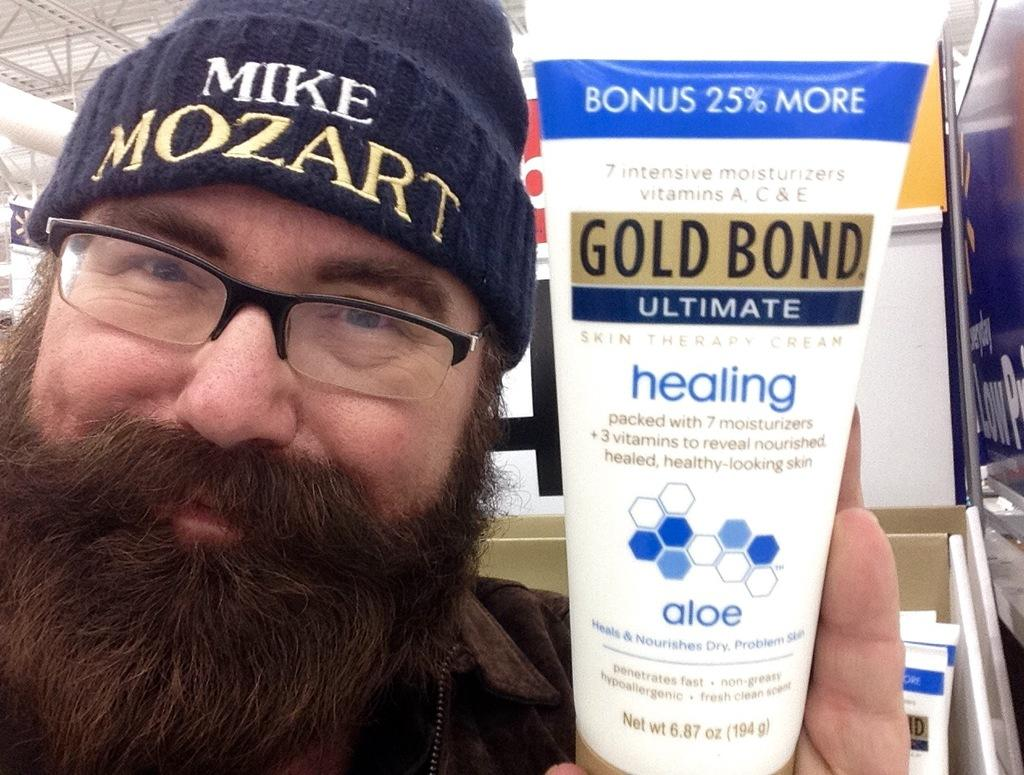<image>
Offer a succinct explanation of the picture presented. MAn holding a tube of GoldBond with bonus 25% more at the top with white lettering. 